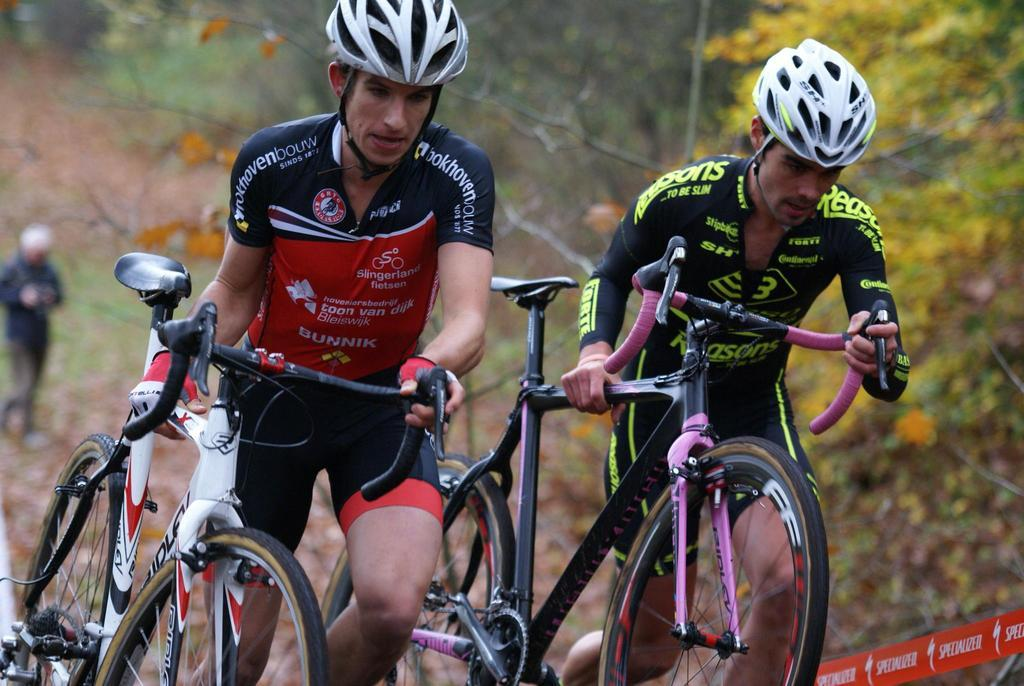How many people are in the image? There are two persons in the image. What are the two persons holding? The two persons are holding bicycles. What can be seen in the background of the image? There is another person standing in the background. What color are the leaves visible in the image? The leaves visible in the image are in yellow color. What type of gun is being used in the competition in the image? There is no gun or competition present in the image; it features two persons holding bicycles. What type of school can be seen in the background of the image? There is no school visible in the background of the image. 